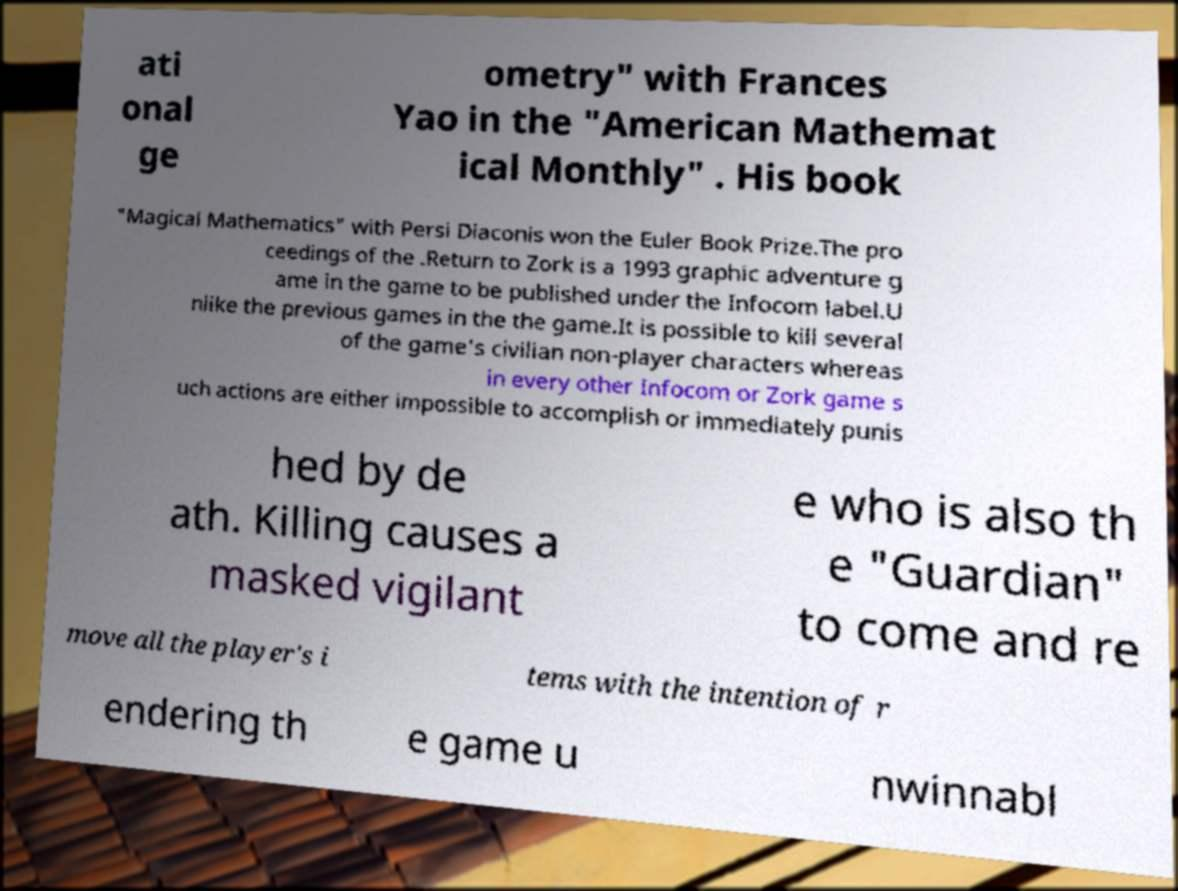For documentation purposes, I need the text within this image transcribed. Could you provide that? ati onal ge ometry" with Frances Yao in the "American Mathemat ical Monthly" . His book "Magical Mathematics" with Persi Diaconis won the Euler Book Prize.The pro ceedings of the .Return to Zork is a 1993 graphic adventure g ame in the game to be published under the Infocom label.U nlike the previous games in the the game.It is possible to kill several of the game's civilian non-player characters whereas in every other Infocom or Zork game s uch actions are either impossible to accomplish or immediately punis hed by de ath. Killing causes a masked vigilant e who is also th e "Guardian" to come and re move all the player's i tems with the intention of r endering th e game u nwinnabl 